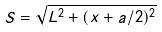Convert formula to latex. <formula><loc_0><loc_0><loc_500><loc_500>S = \sqrt { L ^ { 2 } + ( x + a / 2 ) ^ { 2 } }</formula> 